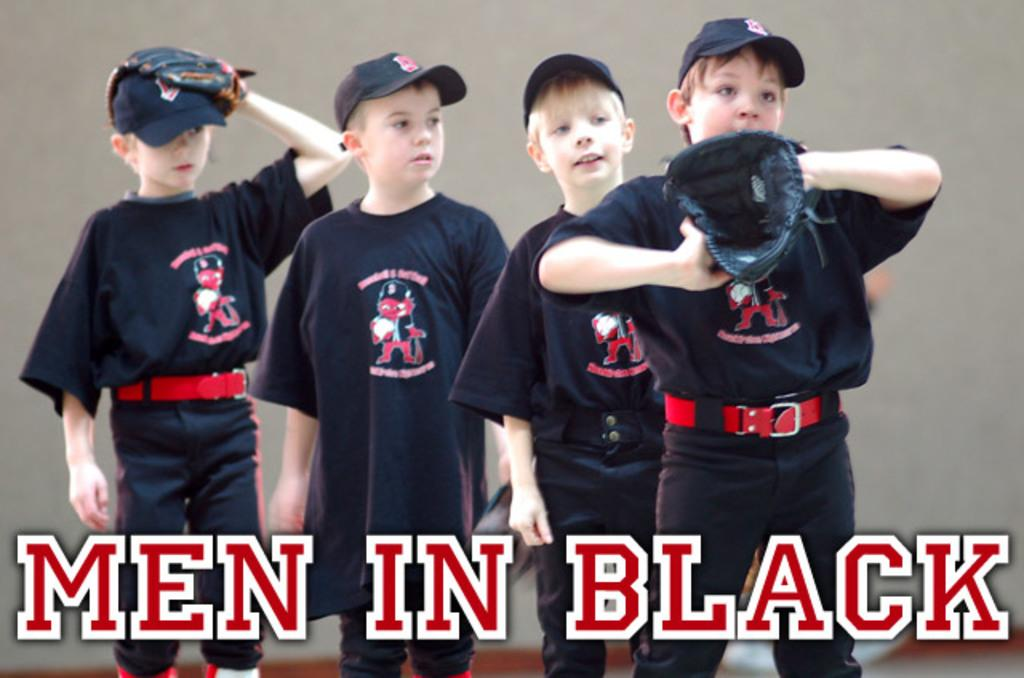<image>
Offer a succinct explanation of the picture presented. Men in black banner in white and red colors. 